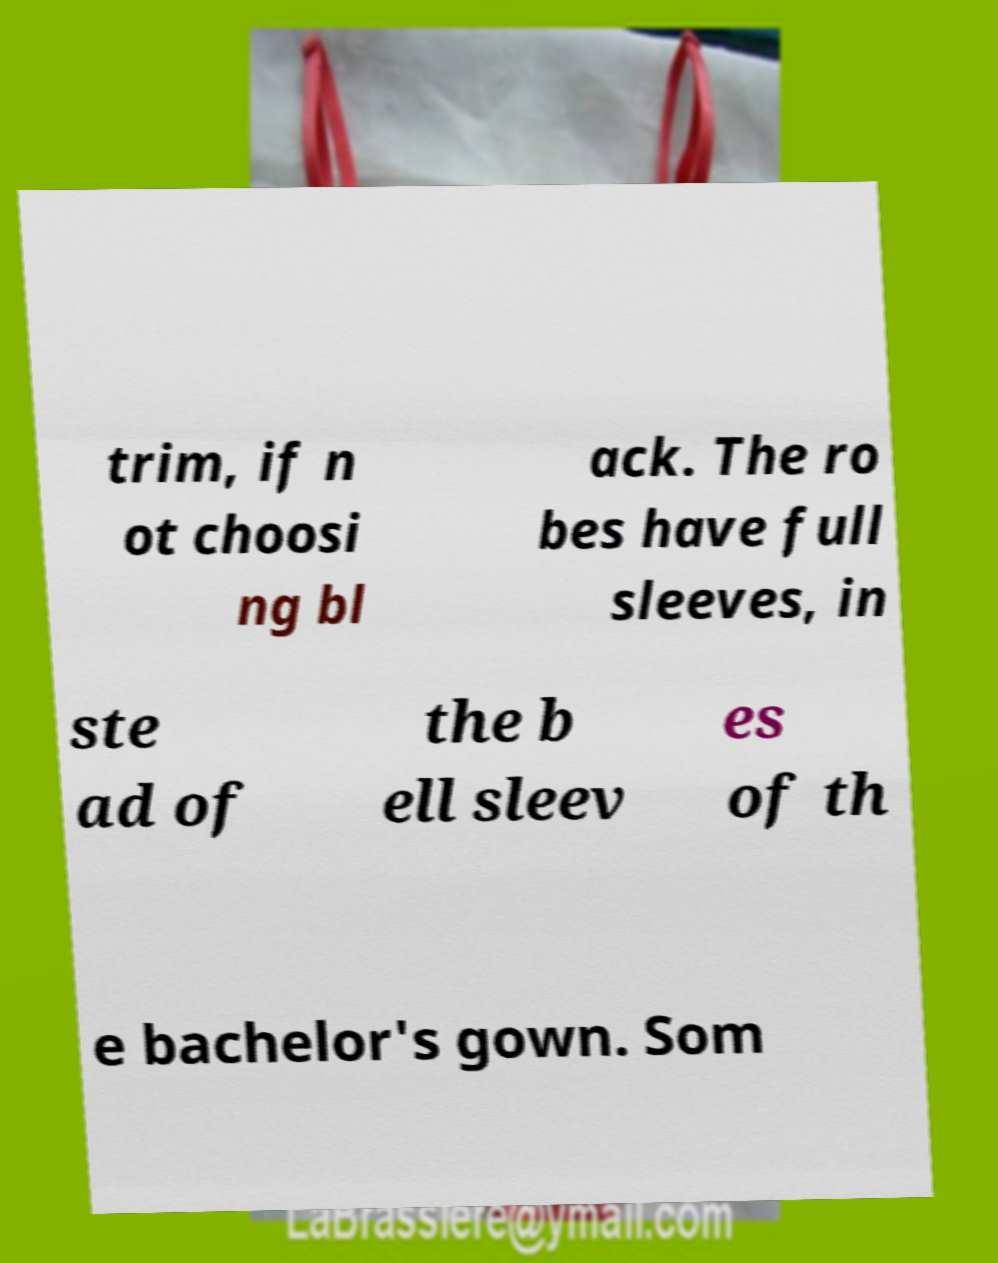I need the written content from this picture converted into text. Can you do that? trim, if n ot choosi ng bl ack. The ro bes have full sleeves, in ste ad of the b ell sleev es of th e bachelor's gown. Som 